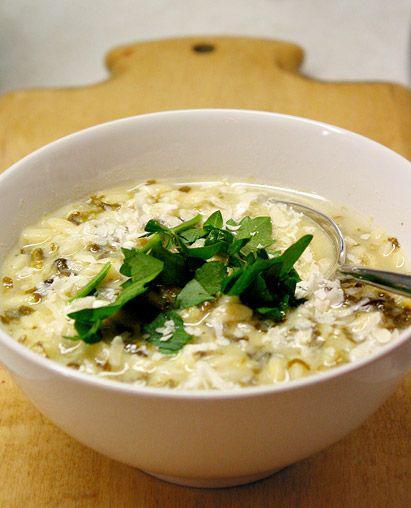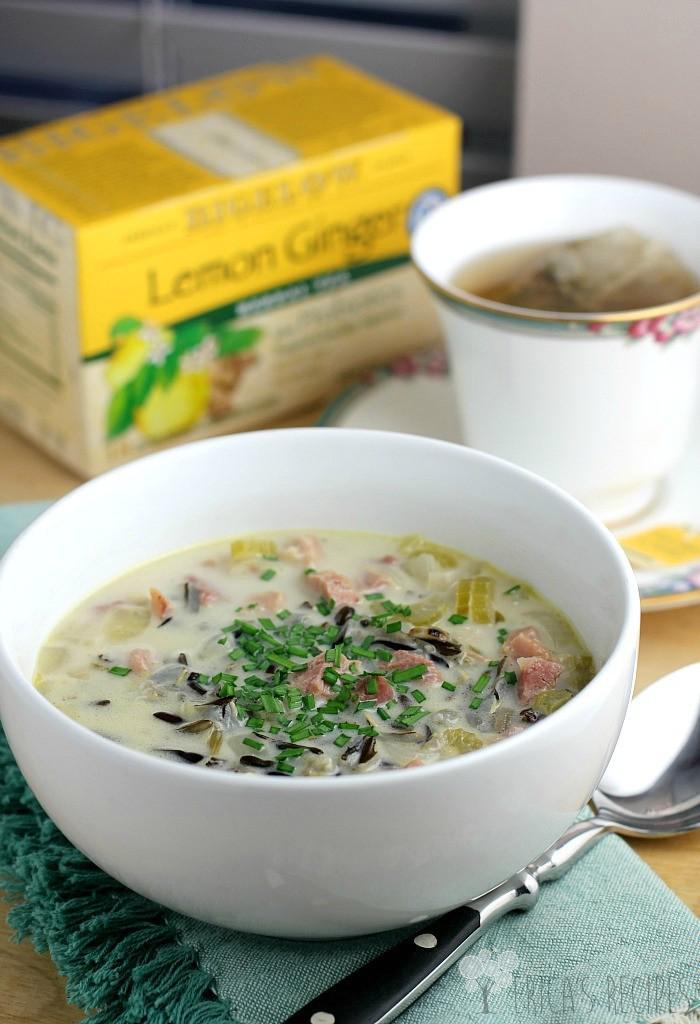The first image is the image on the left, the second image is the image on the right. Considering the images on both sides, is "A silverware spoon is lying on a flat surface nex to a white bowl containing soup." valid? Answer yes or no. Yes. 